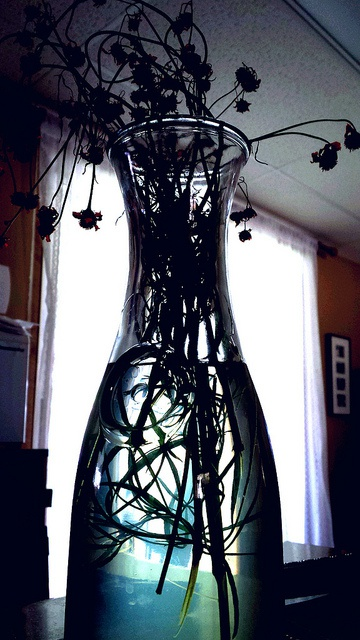Describe the objects in this image and their specific colors. I can see a vase in black, white, gray, and teal tones in this image. 